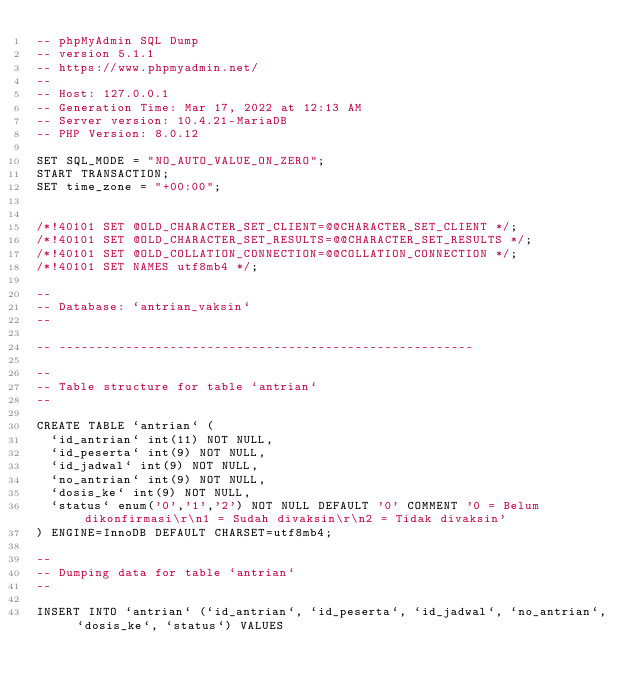<code> <loc_0><loc_0><loc_500><loc_500><_SQL_>-- phpMyAdmin SQL Dump
-- version 5.1.1
-- https://www.phpmyadmin.net/
--
-- Host: 127.0.0.1
-- Generation Time: Mar 17, 2022 at 12:13 AM
-- Server version: 10.4.21-MariaDB
-- PHP Version: 8.0.12

SET SQL_MODE = "NO_AUTO_VALUE_ON_ZERO";
START TRANSACTION;
SET time_zone = "+00:00";


/*!40101 SET @OLD_CHARACTER_SET_CLIENT=@@CHARACTER_SET_CLIENT */;
/*!40101 SET @OLD_CHARACTER_SET_RESULTS=@@CHARACTER_SET_RESULTS */;
/*!40101 SET @OLD_COLLATION_CONNECTION=@@COLLATION_CONNECTION */;
/*!40101 SET NAMES utf8mb4 */;

--
-- Database: `antrian_vaksin`
--

-- --------------------------------------------------------

--
-- Table structure for table `antrian`
--

CREATE TABLE `antrian` (
  `id_antrian` int(11) NOT NULL,
  `id_peserta` int(9) NOT NULL,
  `id_jadwal` int(9) NOT NULL,
  `no_antrian` int(9) NOT NULL,
  `dosis_ke` int(9) NOT NULL,
  `status` enum('0','1','2') NOT NULL DEFAULT '0' COMMENT '0 = Belum dikonfirmasi\r\n1 = Sudah divaksin\r\n2 = Tidak divaksin'
) ENGINE=InnoDB DEFAULT CHARSET=utf8mb4;

--
-- Dumping data for table `antrian`
--

INSERT INTO `antrian` (`id_antrian`, `id_peserta`, `id_jadwal`, `no_antrian`, `dosis_ke`, `status`) VALUES</code> 